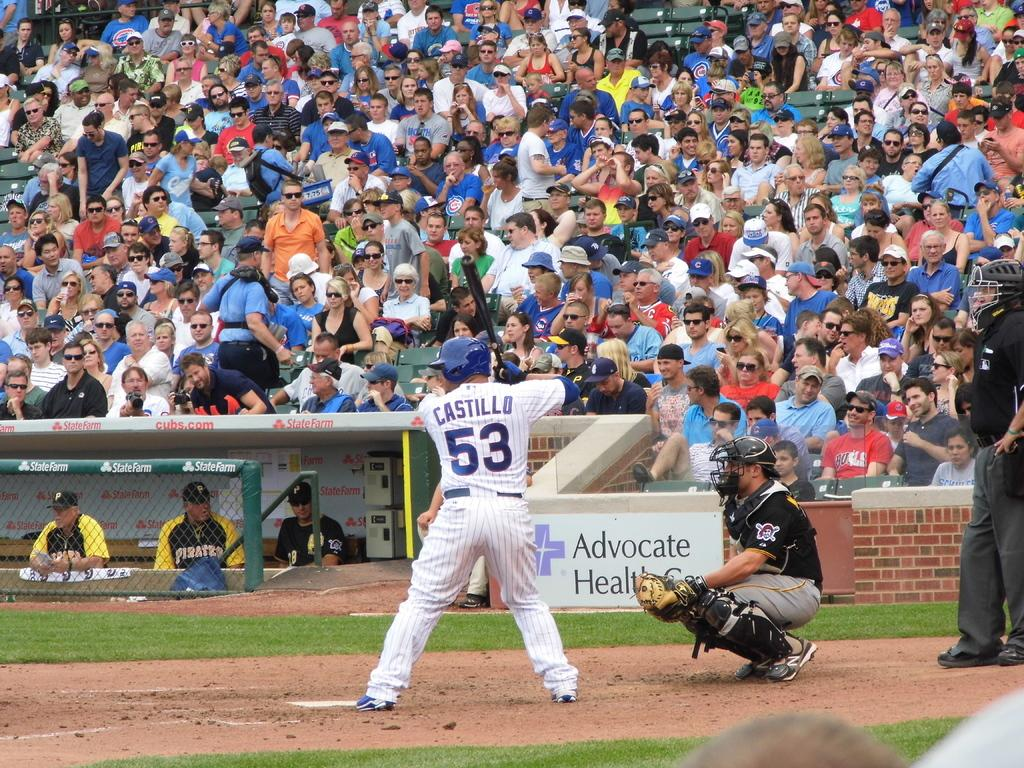<image>
Give a short and clear explanation of the subsequent image. A baseball number 53 with the last name Castillo attempts to hit a ball in a game of baseball. 